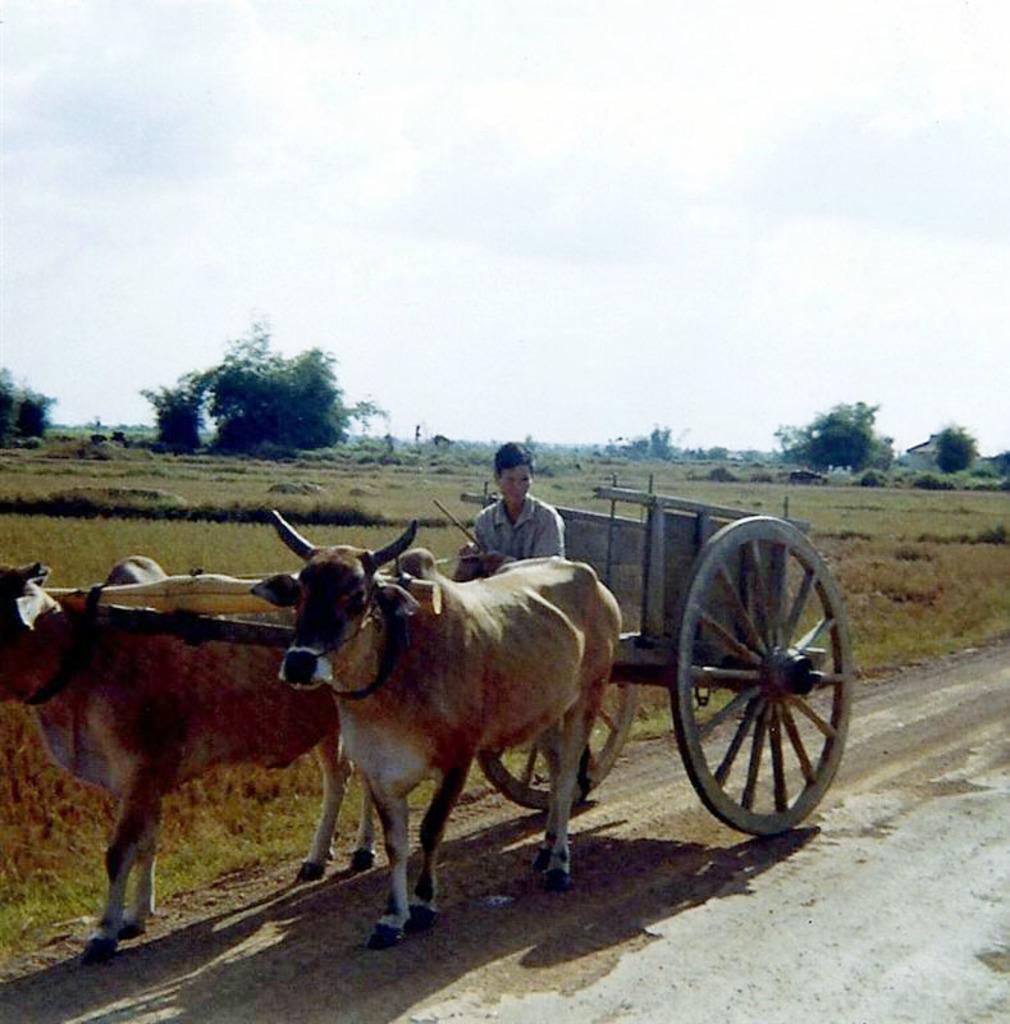In one or two sentences, can you explain what this image depicts? In the image there is a man riding a bullock cart, behind the bullock cart there's a land covered with grass and in the background there are trees. 